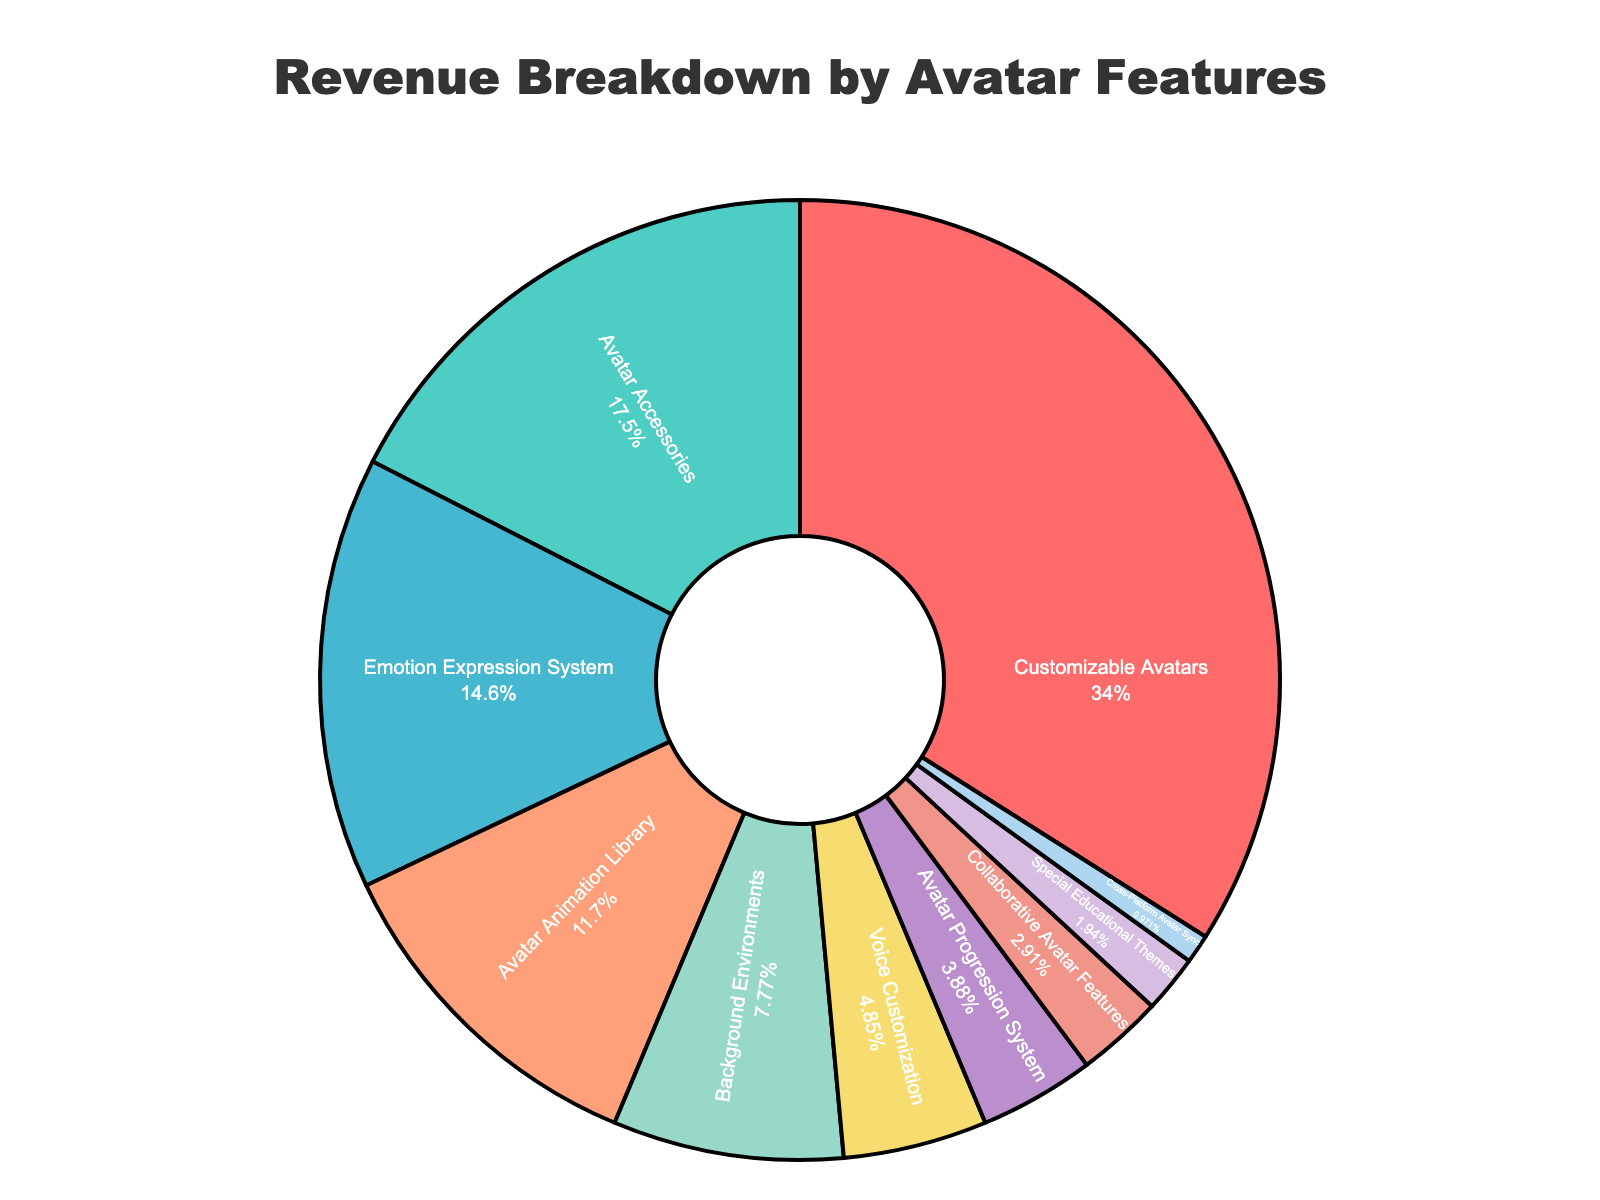What is the largest revenue-generating feature? The pie chart shows that "Customizable Avatars" has the largest portion, indicated by a sector occupying 35% of the pie.
Answer: Customizable Avatars How much more revenue does "Customizable Avatars" generate compared to "Avatar Accessories"? "Customizable Avatars" generates 35% of the revenue while "Avatar Accessories" generates 18%. The difference is calculated as 35% - 18% = 17%.
Answer: 17% Which feature contributes the least to the revenue? The pie chart indicates that "Cross-Platform Avatar Sync" has the smallest sector, representing 1% of the pie.
Answer: Cross-Platform Avatar Sync What is the total revenue percentage generated by "Avatar Animation Library", "Background Environments", and "Emotion Expression System" combined? Add the percentages for the three features: 12% (Avatar Animation Library) + 8% (Background Environments) + 15% (Emotion Expression System) = 35%.
Answer: 35% Is the revenue generated by "Voice Customization" greater than that of "Collaborative Avatar Features"? From the pie chart, "Voice Customization" generates 5% while "Collaborative Avatar Features" generates 3%. Since 5% is greater than 3%, "Voice Customization" generates more revenue.
Answer: Yes How many features contribute to a revenue percentage less than 5%? From the pie chart, the features with less than 5% revenue are "Avatar Progression System" (4%), "Collaborative Avatar Features" (3%), "Special Educational Themes" (2%), and "Cross-Platform Avatar Sync" (1%). There are four such features.
Answer: 4 What is the combined revenue percentage of features excluding "Customizable Avatars"? Subtract the revenue percentage of "Customizable Avatars" from 100%: 100% - 35% = 65%.
Answer: 65% Between "Special Educational Themes" and "Background Environments", which feature generates more revenue and by how much? "Special Educational Themes" generates 2% and "Background Environments" generates 8%. The difference is 8% - 2% = 6%, and "Background Environments" generates more.
Answer: Background Environments, 6% What percentage of the total revenue do the features that generate exactly or more than 10% contribute? The features with 10% or more are "Customizable Avatars" (35%), "Avatar Accessories" (18%), and "Emotion Expression System" (15%). Adding them: 35% + 18% + 15% = 68%.
Answer: 68% What color represents "Voice Customization" in the pie chart? According to the visual attributes, the pie chart uses the 6th color in the custom palette for "Voice Customization," which is yellow.
Answer: Yellow 